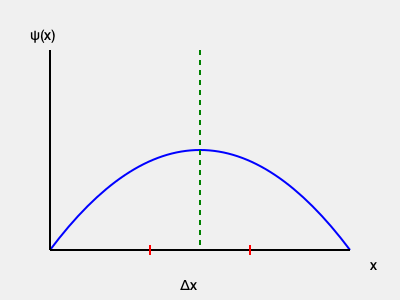Consider a particle described by the wave function $\psi(x)$ shown in the graph. If we measure its position with unprecedented accuracy, achieving a position uncertainty of $\Delta x = 10^{-15}$ m, what is the minimum uncertainty in the particle's momentum according to the Heisenberg uncertainty principle? How does this result challenge our classical intuition about simultaneous measurement of position and momentum? To solve this problem, we'll follow these steps:

1) Recall the Heisenberg uncertainty principle:
   $$\Delta x \cdot \Delta p \geq \frac{\hbar}{2}$$
   where $\hbar$ is the reduced Planck constant.

2) We're given $\Delta x = 10^{-15}$ m. We need to find the minimum $\Delta p$.

3) The minimum uncertainty occurs when the inequality becomes an equality:
   $$\Delta x \cdot \Delta p = \frac{\hbar}{2}$$

4) Solve for $\Delta p$:
   $$\Delta p = \frac{\hbar}{2\Delta x}$$

5) Substitute the values:
   $\hbar \approx 1.0545718 \times 10^{-34}$ J⋅s
   $\Delta x = 10^{-15}$ m

   $$\Delta p = \frac{1.0545718 \times 10^{-34}}{2 \times 10^{-15}} \approx 5.27 \times 10^{-20}$$ kg⋅m/s

6) This result challenges classical intuition because:
   a) The more precisely we measure position, the less precisely we can know momentum, and vice versa.
   b) There's a fundamental limit to how well we can simultaneously know both position and momentum.
   c) This is not due to measurement imprecision, but a fundamental property of quantum systems.
   d) It suggests that particles don't have well-defined trajectories in the classical sense.

This principle undermines the deterministic view of classical physics and introduces inherent uncertainties at the quantum level, challenging our macroscopic intuitions about measurement and prediction.
Answer: $\Delta p \approx 5.27 \times 10^{-20}$ kg⋅m/s 